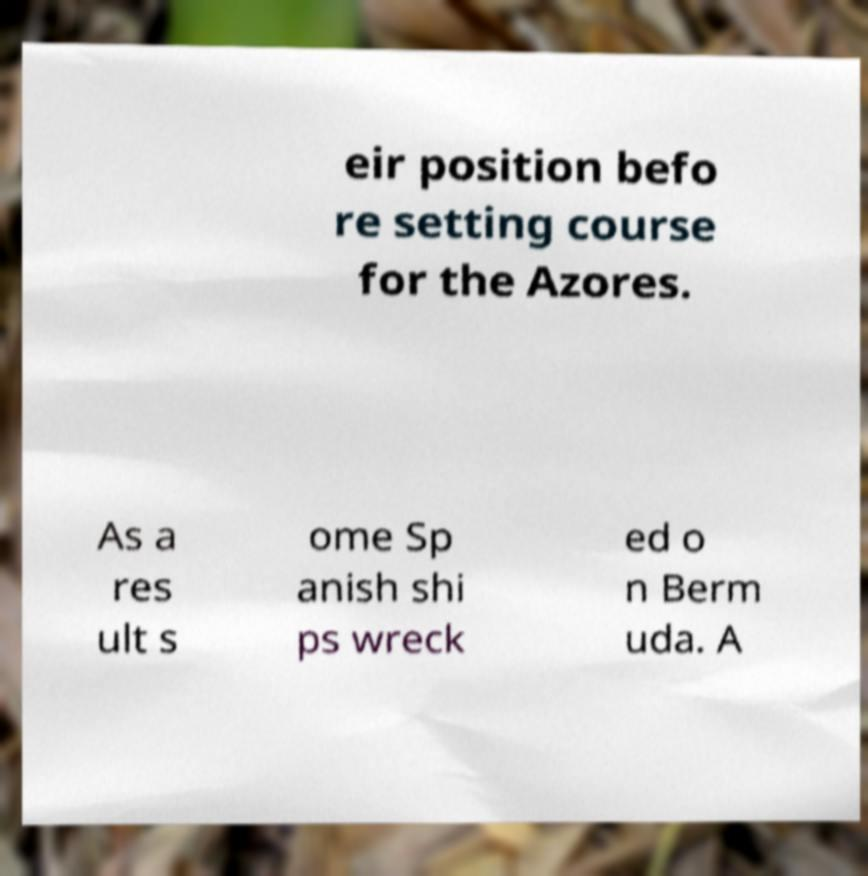Could you assist in decoding the text presented in this image and type it out clearly? eir position befo re setting course for the Azores. As a res ult s ome Sp anish shi ps wreck ed o n Berm uda. A 